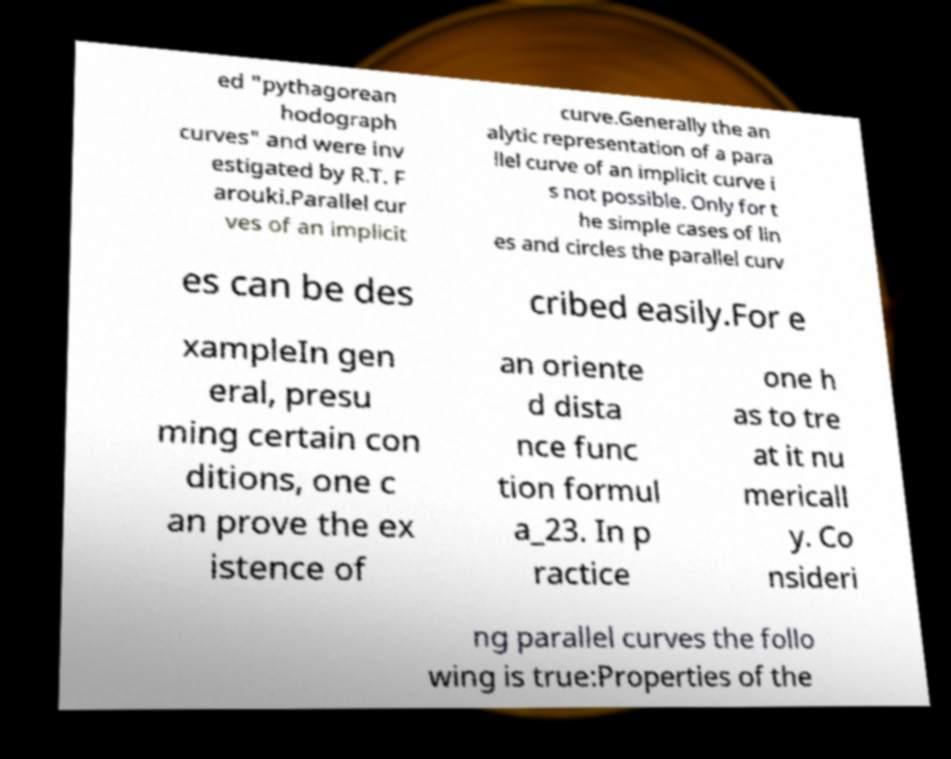What messages or text are displayed in this image? I need them in a readable, typed format. ed "pythagorean hodograph curves" and were inv estigated by R.T. F arouki.Parallel cur ves of an implicit curve.Generally the an alytic representation of a para llel curve of an implicit curve i s not possible. Only for t he simple cases of lin es and circles the parallel curv es can be des cribed easily.For e xampleIn gen eral, presu ming certain con ditions, one c an prove the ex istence of an oriente d dista nce func tion formul a_23. In p ractice one h as to tre at it nu mericall y. Co nsideri ng parallel curves the follo wing is true:Properties of the 